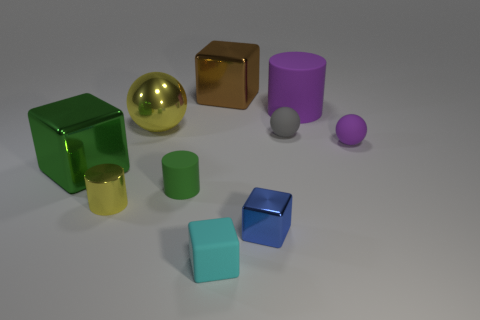How many other things are the same shape as the big brown object?
Your answer should be very brief. 3. How many gray objects are spheres or metallic objects?
Ensure brevity in your answer.  1. Does the tiny yellow object have the same shape as the green rubber thing?
Keep it short and to the point. Yes. Is there a small yellow metallic thing that is to the right of the rubber ball to the right of the purple cylinder?
Provide a short and direct response. No. Are there an equal number of shiny objects that are to the right of the cyan rubber thing and cyan rubber objects?
Ensure brevity in your answer.  No. How many other objects are the same size as the gray matte object?
Offer a terse response. 5. Is the green thing left of the yellow sphere made of the same material as the small ball in front of the tiny gray thing?
Give a very brief answer. No. There is a shiny thing that is behind the matte cylinder behind the green rubber cylinder; what size is it?
Keep it short and to the point. Large. Are there any metal balls that have the same color as the large matte object?
Your answer should be compact. No. Does the tiny shiny thing left of the blue metallic object have the same color as the large object that is right of the small blue cube?
Give a very brief answer. No. 